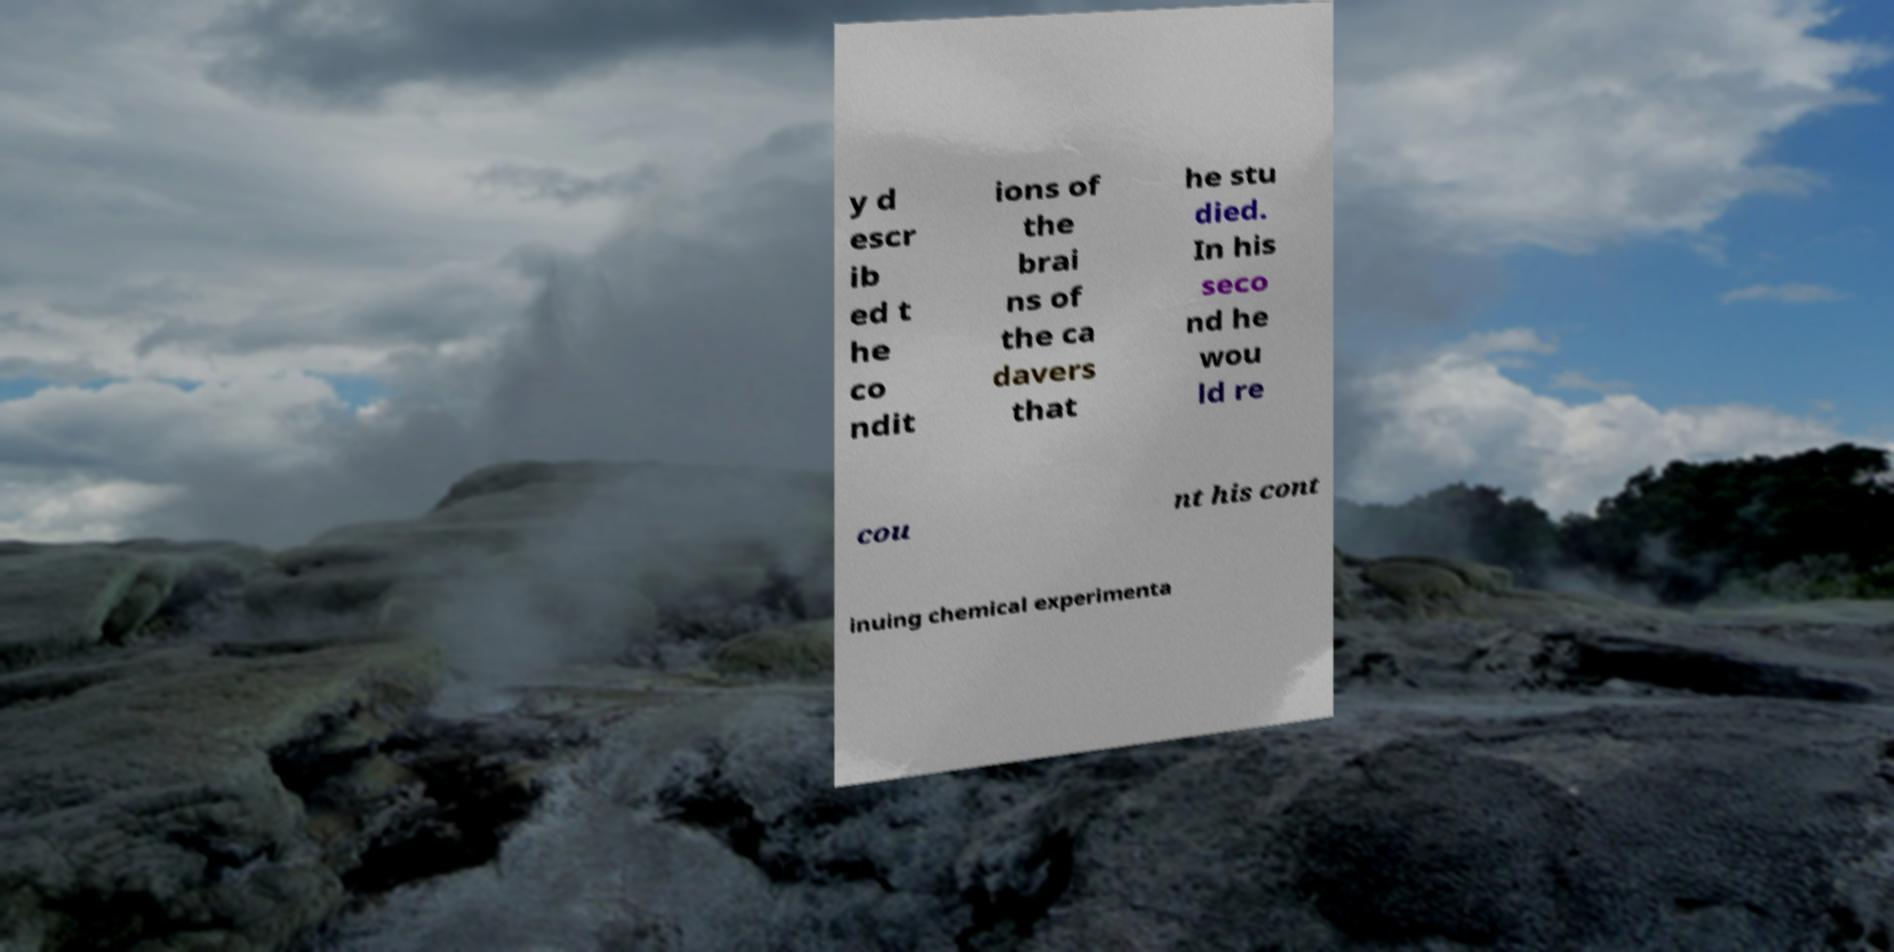Please read and relay the text visible in this image. What does it say? y d escr ib ed t he co ndit ions of the brai ns of the ca davers that he stu died. In his seco nd he wou ld re cou nt his cont inuing chemical experimenta 